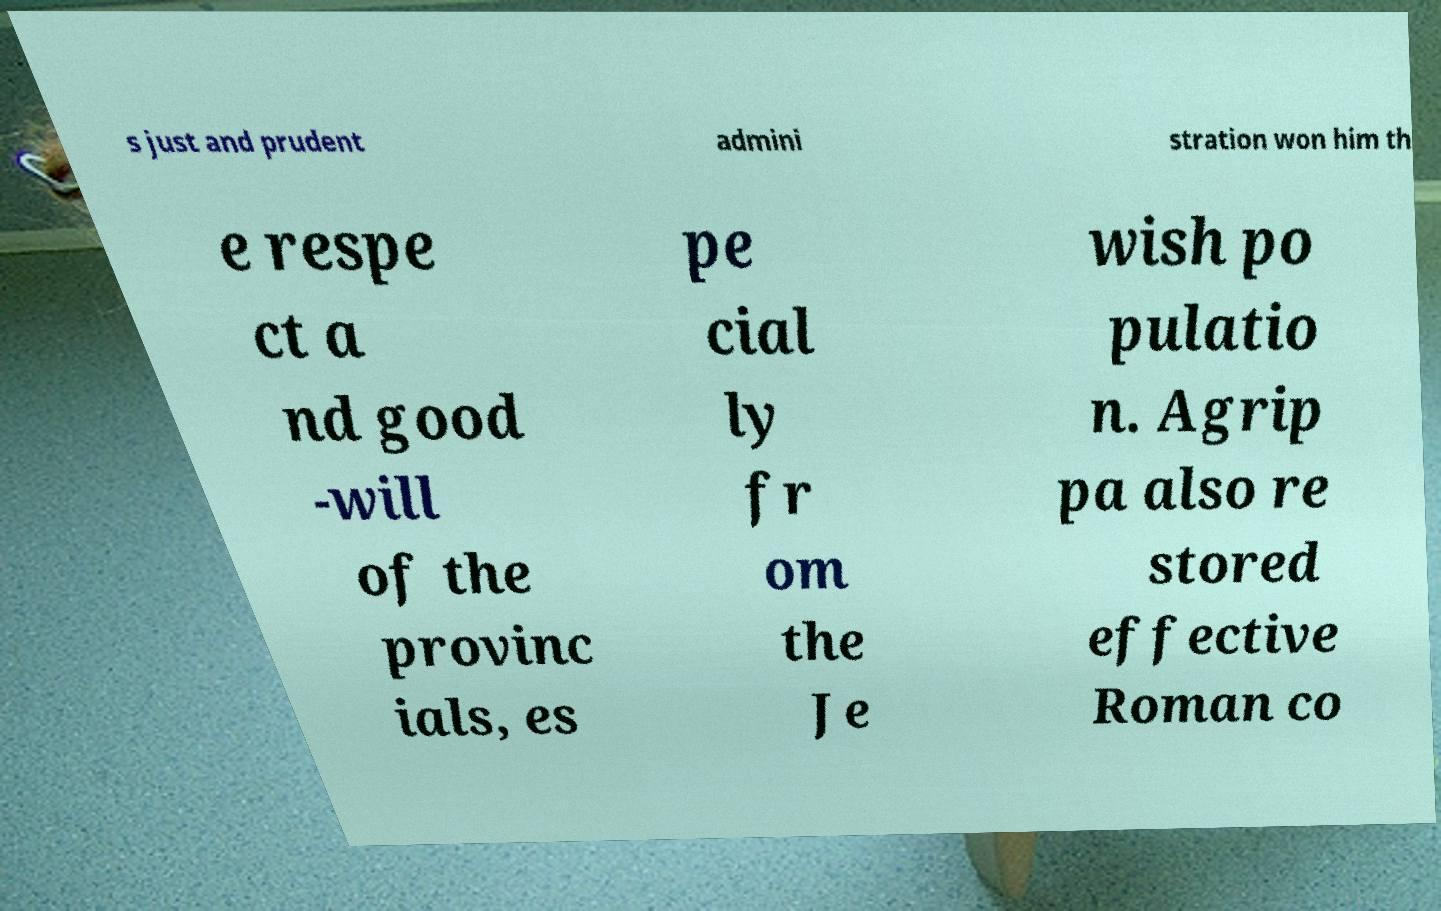For documentation purposes, I need the text within this image transcribed. Could you provide that? s just and prudent admini stration won him th e respe ct a nd good -will of the provinc ials, es pe cial ly fr om the Je wish po pulatio n. Agrip pa also re stored effective Roman co 